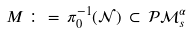Convert formula to latex. <formula><loc_0><loc_0><loc_500><loc_500>M \, \colon = \, \pi ^ { - 1 } _ { 0 } ( { \mathcal { N } } ) \, \subset \, { \mathcal { P } } { \mathcal { M } } ^ { \alpha } _ { s }</formula> 